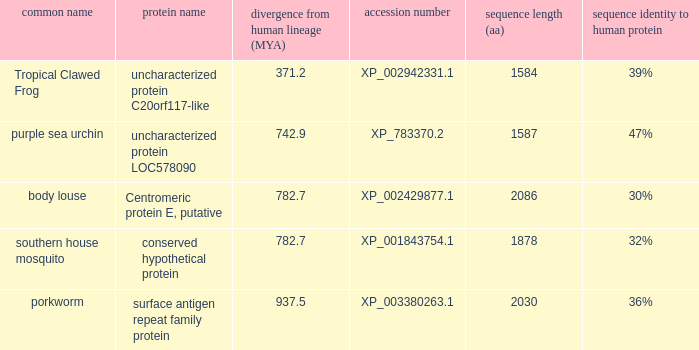5? XP_003380263.1. 